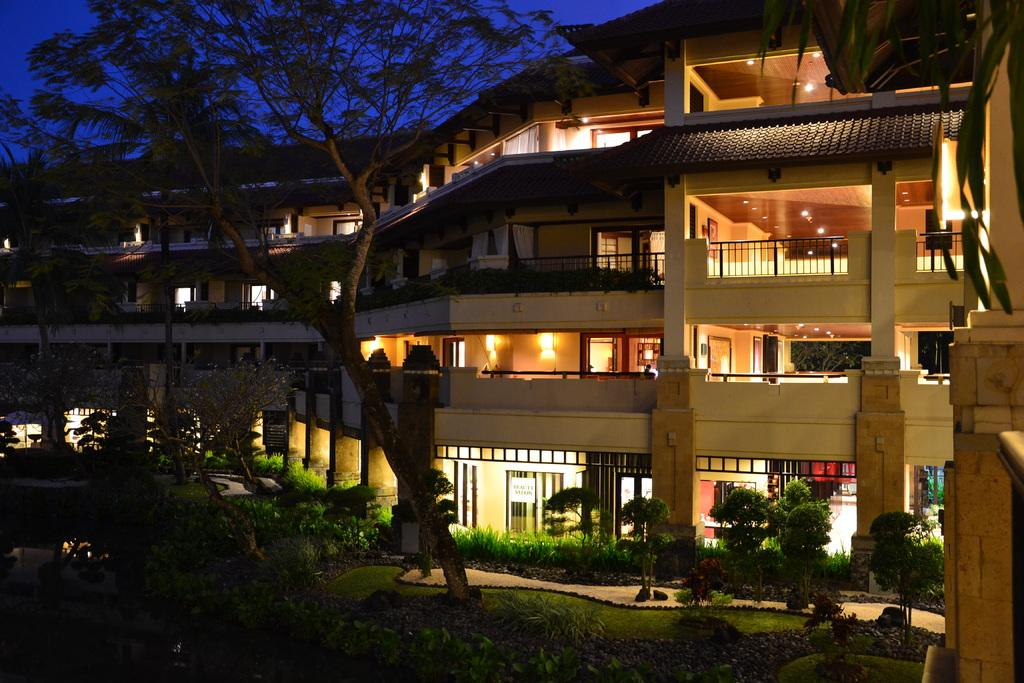What type of structure is visible in the image? There is a building with lights in the image. What can be seen in front of the building? Trees, grass, and plants are present in front of the building. What is visible in the background of the image? The sky is visible in the background of the image. How many dolls are sitting on the arch in the image? There are no dolls or arches present in the image. 